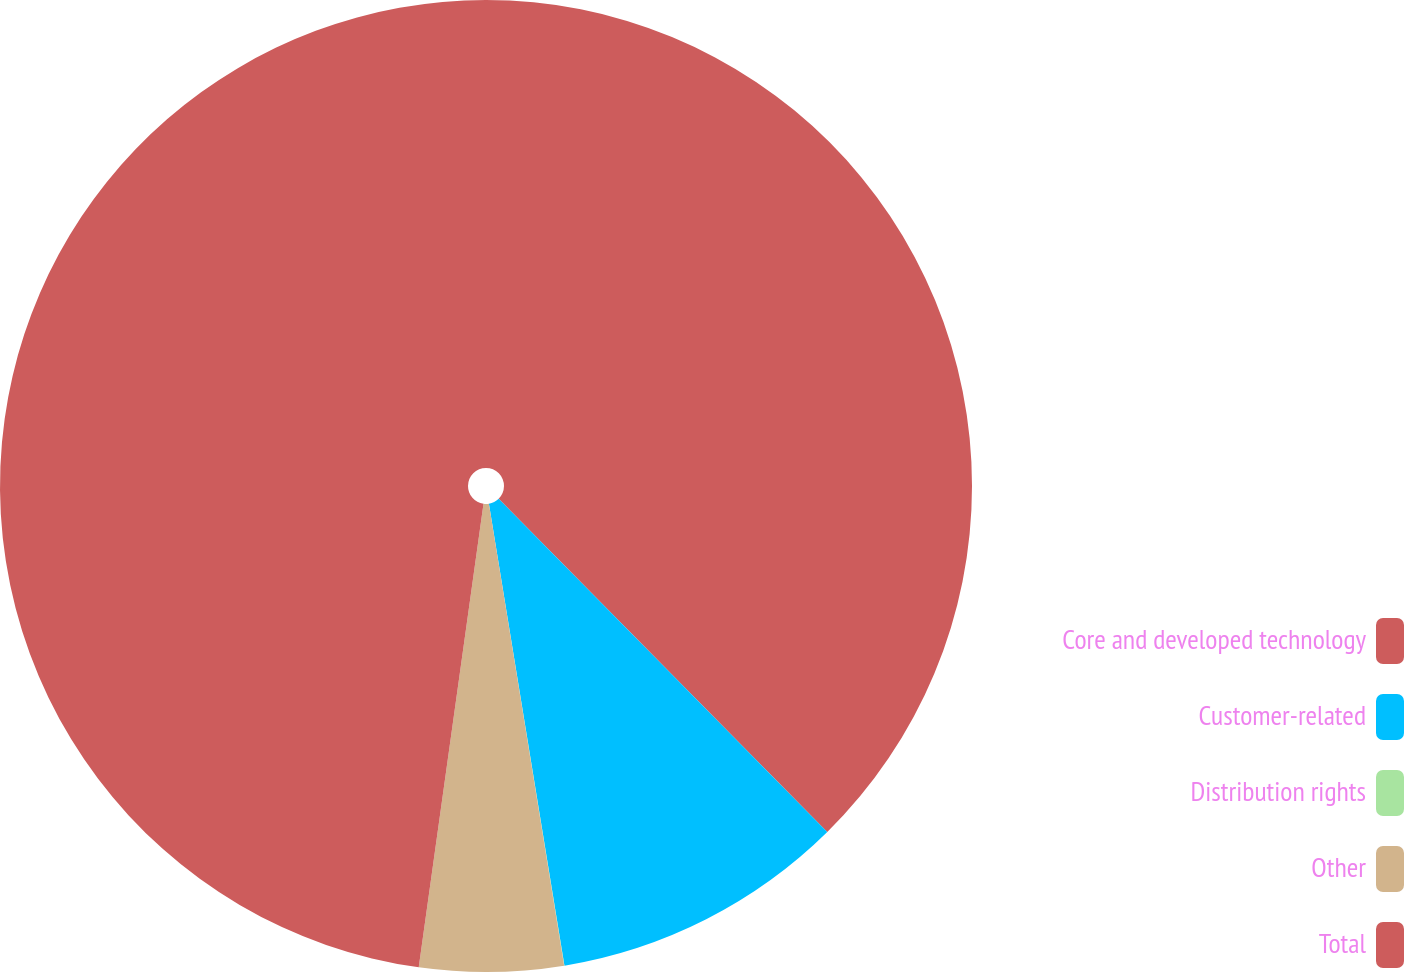<chart> <loc_0><loc_0><loc_500><loc_500><pie_chart><fcel>Core and developed technology<fcel>Customer-related<fcel>Distribution rights<fcel>Other<fcel>Total<nl><fcel>37.61%<fcel>9.81%<fcel>0.01%<fcel>4.78%<fcel>47.79%<nl></chart> 